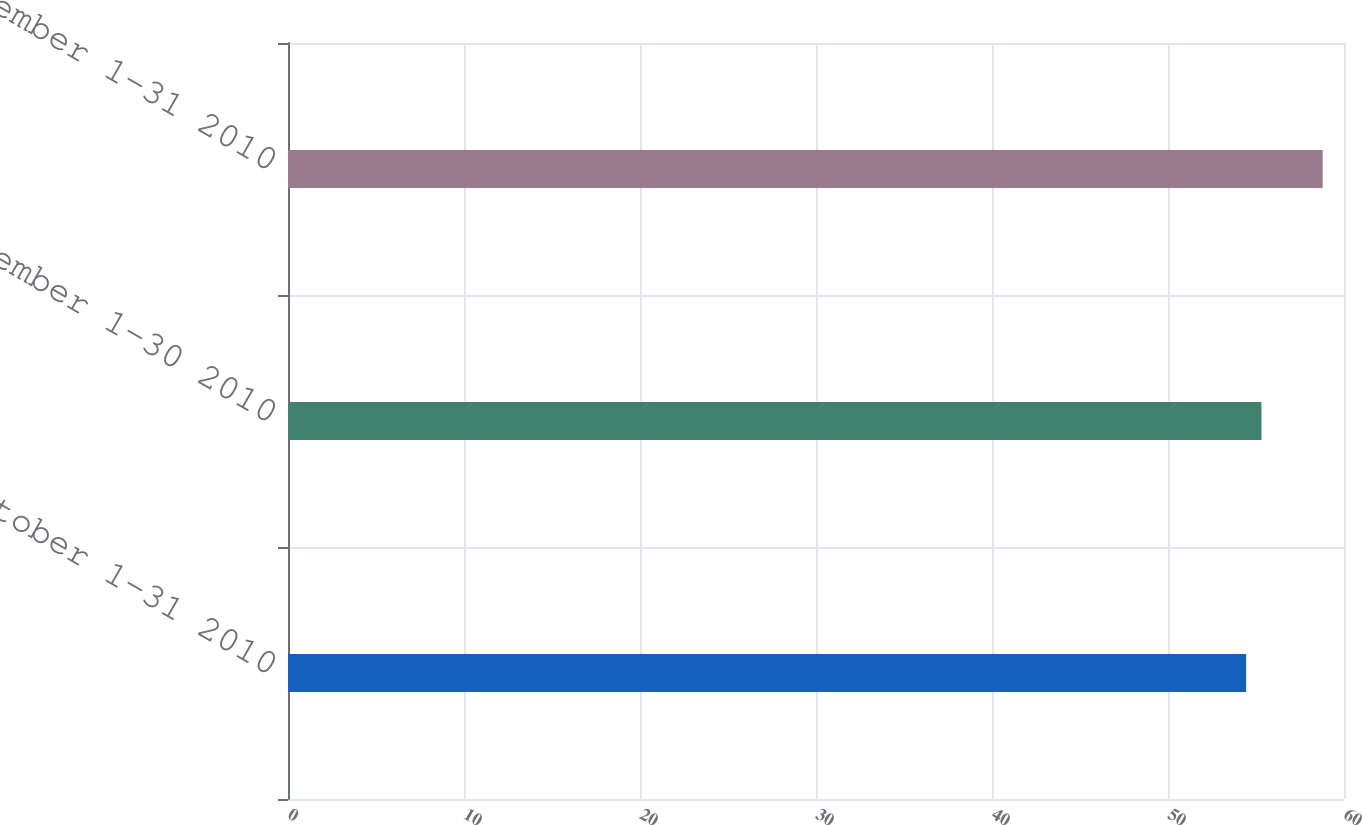Convert chart. <chart><loc_0><loc_0><loc_500><loc_500><bar_chart><fcel>October 1-31 2010<fcel>November 1-30 2010<fcel>December 1-31 2010<nl><fcel>54.44<fcel>55.31<fcel>58.79<nl></chart> 